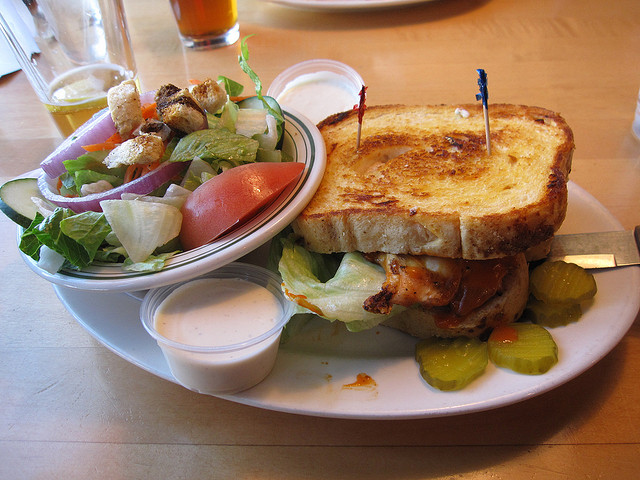What kind of bread is that? The bread in the picture appears to be a thickly sliced, grilled bread possibly indicating it's Texas toast, ideal for grilled sandwiches. 